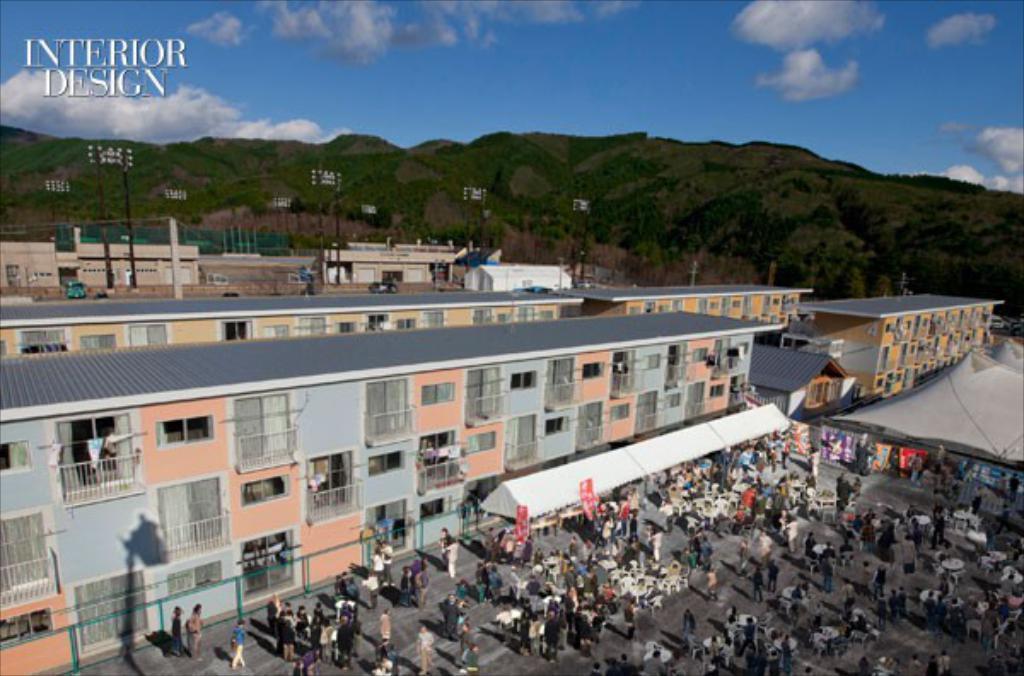How would you summarize this image in a sentence or two? In the picture I can see buildings, people standing on the ground, fence, tents and some other objects on the ground. In the background I can see the sky, hills, poles and some other objects. On the top left side of the image I can see a watermark. 